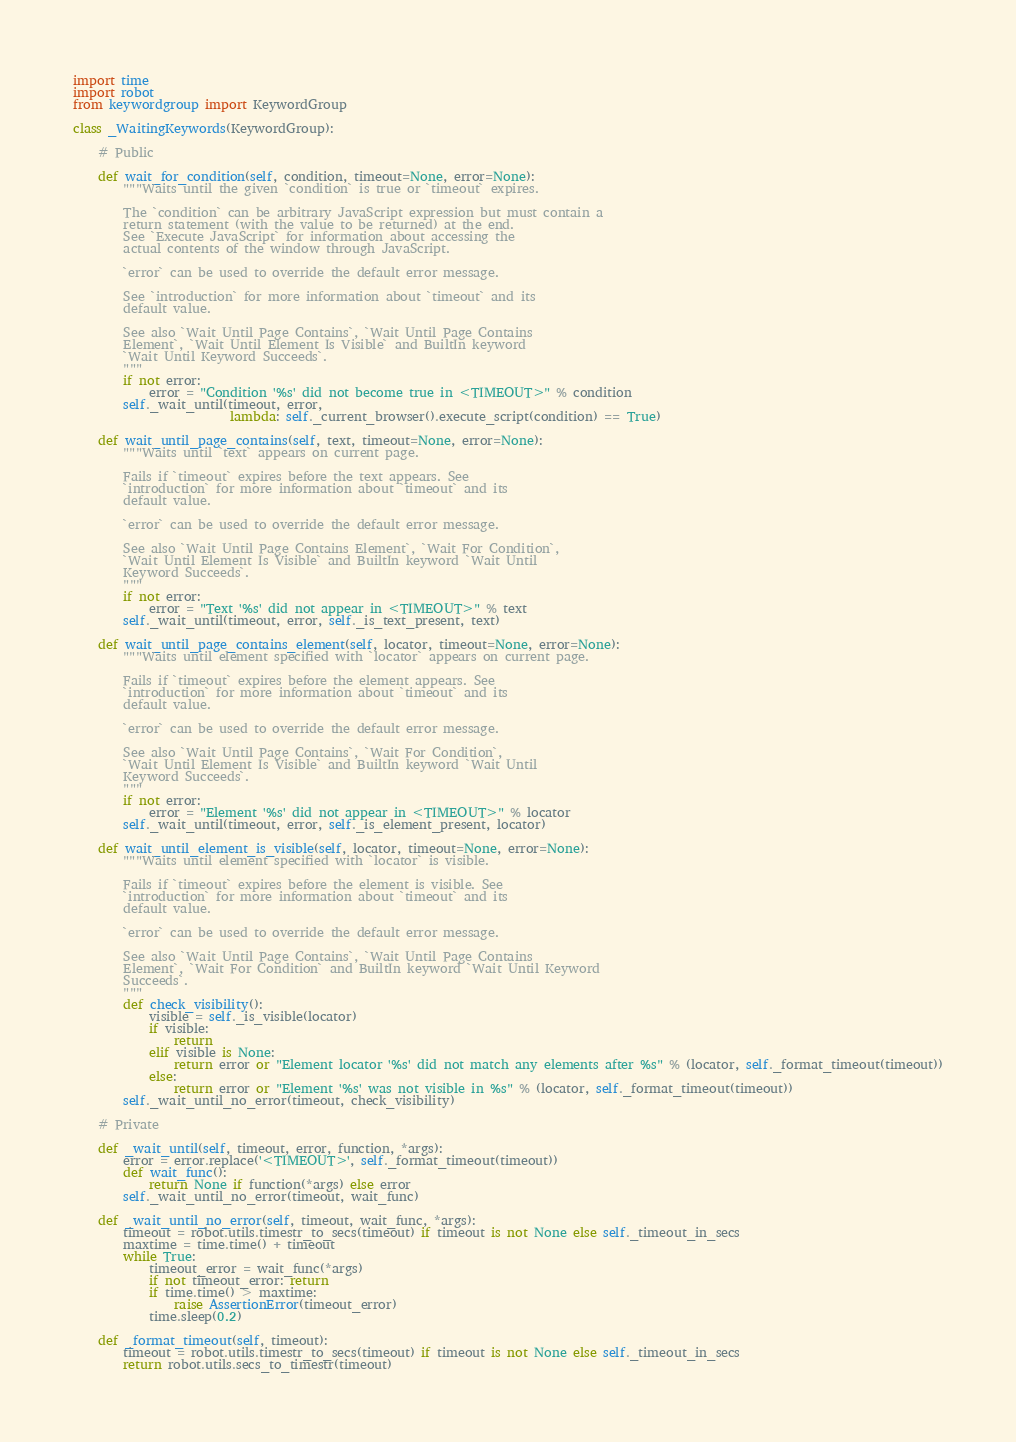<code> <loc_0><loc_0><loc_500><loc_500><_Python_>import time
import robot
from keywordgroup import KeywordGroup

class _WaitingKeywords(KeywordGroup):

    # Public

    def wait_for_condition(self, condition, timeout=None, error=None):
        """Waits until the given `condition` is true or `timeout` expires.

        The `condition` can be arbitrary JavaScript expression but must contain a 
        return statement (with the value to be returned) at the end.
        See `Execute JavaScript` for information about accessing the
        actual contents of the window through JavaScript.

        `error` can be used to override the default error message.

        See `introduction` for more information about `timeout` and its
        default value.

        See also `Wait Until Page Contains`, `Wait Until Page Contains
        Element`, `Wait Until Element Is Visible` and BuiltIn keyword
        `Wait Until Keyword Succeeds`.
        """
        if not error:
            error = "Condition '%s' did not become true in <TIMEOUT>" % condition
        self._wait_until(timeout, error,
                         lambda: self._current_browser().execute_script(condition) == True)

    def wait_until_page_contains(self, text, timeout=None, error=None):
        """Waits until `text` appears on current page.

        Fails if `timeout` expires before the text appears. See
        `introduction` for more information about `timeout` and its
        default value.

        `error` can be used to override the default error message.

        See also `Wait Until Page Contains Element`, `Wait For Condition`,
        `Wait Until Element Is Visible` and BuiltIn keyword `Wait Until
        Keyword Succeeds`.
        """
        if not error:
            error = "Text '%s' did not appear in <TIMEOUT>" % text
        self._wait_until(timeout, error, self._is_text_present, text)

    def wait_until_page_contains_element(self, locator, timeout=None, error=None):
        """Waits until element specified with `locator` appears on current page.

        Fails if `timeout` expires before the element appears. See
        `introduction` for more information about `timeout` and its
        default value.

        `error` can be used to override the default error message.

        See also `Wait Until Page Contains`, `Wait For Condition`,
        `Wait Until Element Is Visible` and BuiltIn keyword `Wait Until
        Keyword Succeeds`.
        """
        if not error:
            error = "Element '%s' did not appear in <TIMEOUT>" % locator
        self._wait_until(timeout, error, self._is_element_present, locator)

    def wait_until_element_is_visible(self, locator, timeout=None, error=None):
        """Waits until element specified with `locator` is visible.

        Fails if `timeout` expires before the element is visible. See
        `introduction` for more information about `timeout` and its
        default value.

        `error` can be used to override the default error message.

        See also `Wait Until Page Contains`, `Wait Until Page Contains 
        Element`, `Wait For Condition` and BuiltIn keyword `Wait Until Keyword
        Succeeds`.
        """
        def check_visibility():
            visible = self._is_visible(locator)
            if visible:
                return
            elif visible is None:
                return error or "Element locator '%s' did not match any elements after %s" % (locator, self._format_timeout(timeout))
            else:
                return error or "Element '%s' was not visible in %s" % (locator, self._format_timeout(timeout))
        self._wait_until_no_error(timeout, check_visibility)

    # Private

    def _wait_until(self, timeout, error, function, *args):
        error = error.replace('<TIMEOUT>', self._format_timeout(timeout))
        def wait_func():
            return None if function(*args) else error
        self._wait_until_no_error(timeout, wait_func)

    def _wait_until_no_error(self, timeout, wait_func, *args):
        timeout = robot.utils.timestr_to_secs(timeout) if timeout is not None else self._timeout_in_secs
        maxtime = time.time() + timeout
        while True:
            timeout_error = wait_func(*args)
            if not timeout_error: return
            if time.time() > maxtime:
                raise AssertionError(timeout_error)
            time.sleep(0.2)

    def _format_timeout(self, timeout):
        timeout = robot.utils.timestr_to_secs(timeout) if timeout is not None else self._timeout_in_secs
        return robot.utils.secs_to_timestr(timeout)
</code> 